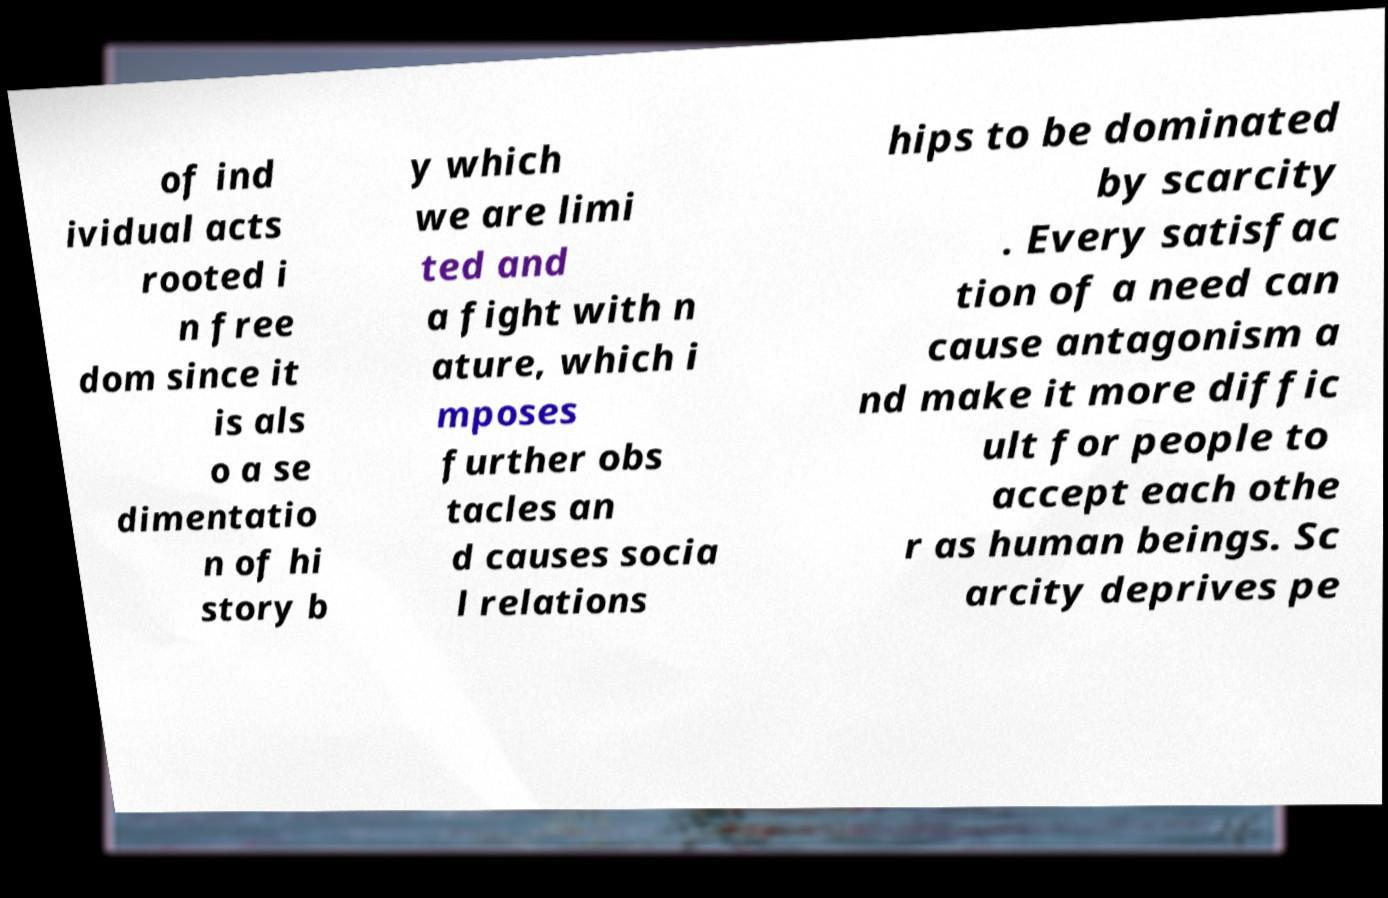Can you accurately transcribe the text from the provided image for me? of ind ividual acts rooted i n free dom since it is als o a se dimentatio n of hi story b y which we are limi ted and a fight with n ature, which i mposes further obs tacles an d causes socia l relations hips to be dominated by scarcity . Every satisfac tion of a need can cause antagonism a nd make it more diffic ult for people to accept each othe r as human beings. Sc arcity deprives pe 